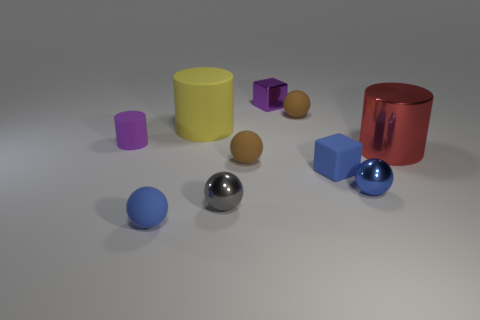Subtract all red blocks. How many brown balls are left? 2 Subtract all matte cylinders. How many cylinders are left? 1 Subtract all gray balls. How many balls are left? 4 Subtract 1 balls. How many balls are left? 4 Subtract all blocks. How many objects are left? 8 Subtract all gray cylinders. Subtract all brown blocks. How many cylinders are left? 3 Subtract all purple blocks. Subtract all red metal cylinders. How many objects are left? 8 Add 4 big red shiny objects. How many big red shiny objects are left? 5 Add 8 tiny red matte objects. How many tiny red matte objects exist? 8 Subtract 0 yellow blocks. How many objects are left? 10 